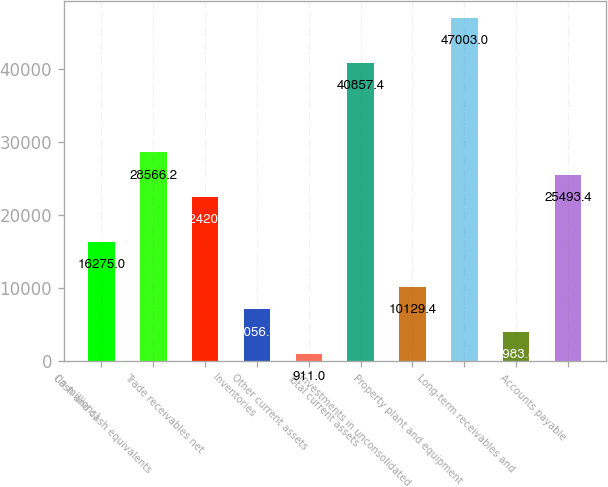<chart> <loc_0><loc_0><loc_500><loc_500><bar_chart><fcel>(in millions)<fcel>Cash and cash equivalents<fcel>Trade receivables net<fcel>Inventories<fcel>Other current assets<fcel>Total current assets<fcel>Investments in unconsolidated<fcel>Property plant and equipment<fcel>Long-term receivables and<fcel>Accounts payable<nl><fcel>16275<fcel>28566.2<fcel>22420.6<fcel>7056.6<fcel>911<fcel>40857.4<fcel>10129.4<fcel>47003<fcel>3983.8<fcel>25493.4<nl></chart> 